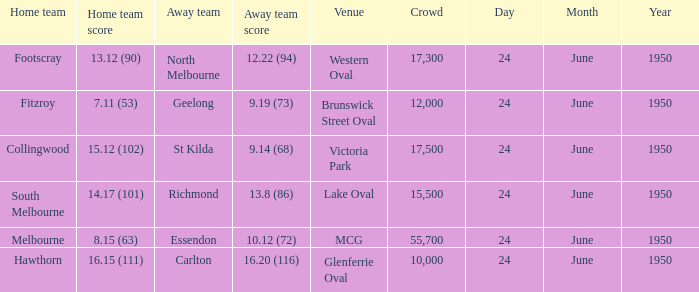Help me parse the entirety of this table. {'header': ['Home team', 'Home team score', 'Away team', 'Away team score', 'Venue', 'Crowd', 'Day', 'Month', 'Year'], 'rows': [['Footscray', '13.12 (90)', 'North Melbourne', '12.22 (94)', 'Western Oval', '17,300', '24', 'June', '1950'], ['Fitzroy', '7.11 (53)', 'Geelong', '9.19 (73)', 'Brunswick Street Oval', '12,000', '24', 'June', '1950'], ['Collingwood', '15.12 (102)', 'St Kilda', '9.14 (68)', 'Victoria Park', '17,500', '24', 'June', '1950'], ['South Melbourne', '14.17 (101)', 'Richmond', '13.8 (86)', 'Lake Oval', '15,500', '24', 'June', '1950'], ['Melbourne', '8.15 (63)', 'Essendon', '10.12 (72)', 'MCG', '55,700', '24', 'June', '1950'], ['Hawthorn', '16.15 (111)', 'Carlton', '16.20 (116)', 'Glenferrie Oval', '10,000', '24', 'June', '1950']]} When was the game where the away team had a score of 13.8 (86)? 24 June 1950. 